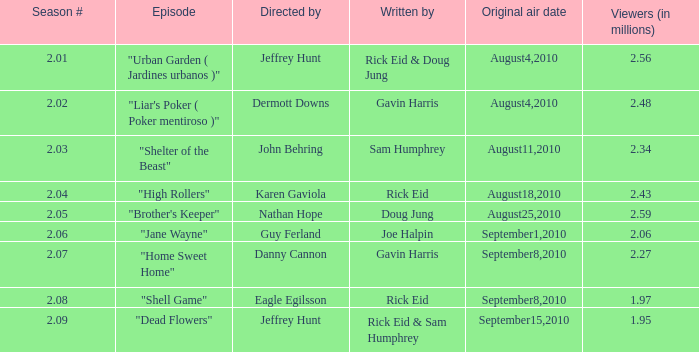48 million, what is the original airing date? August4,2010. 